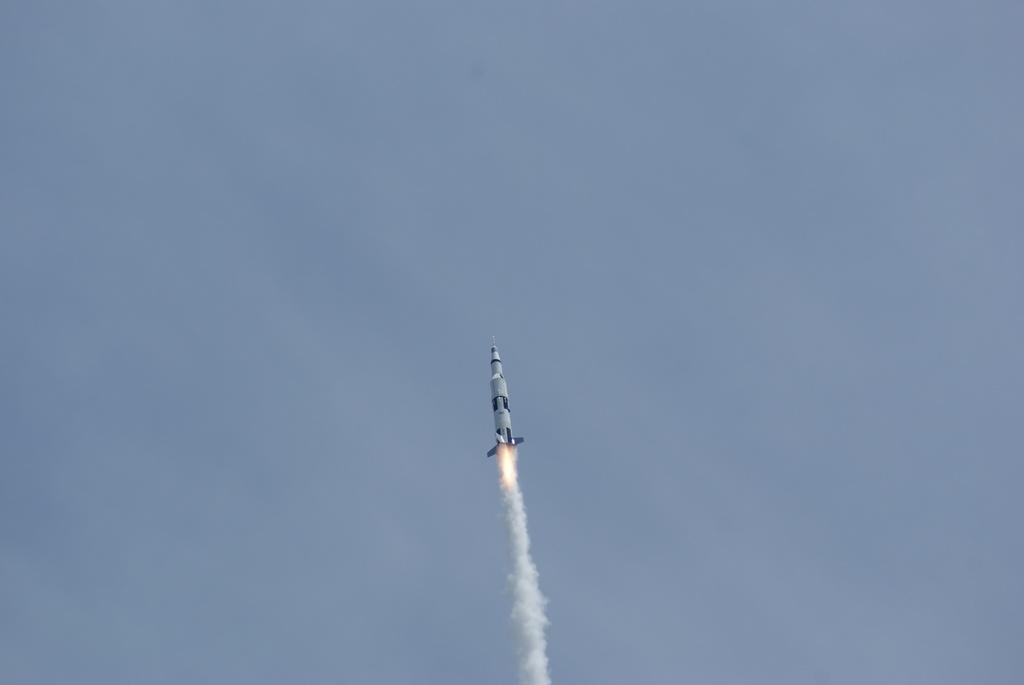What is the main subject of the image? The main subject of the image is a rocket. Where is the rocket located in the image? The rocket is in the sky. What can be observed coming out of the rocket? Smoke is coming out of the rocket. How many legs does the rocket have in the image? Rockets do not have legs; they are launched vertically and do not require legs for support or movement. 